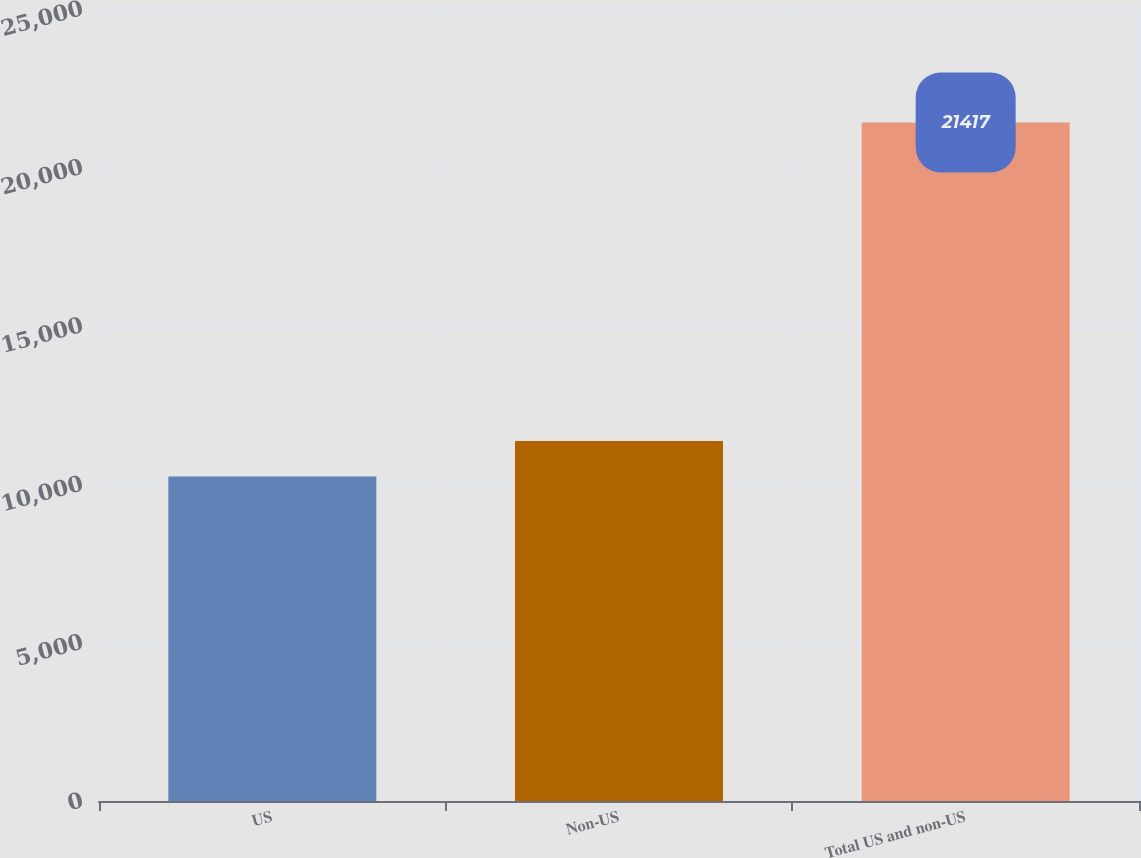Convert chart. <chart><loc_0><loc_0><loc_500><loc_500><bar_chart><fcel>US<fcel>Non-US<fcel>Total US and non-US<nl><fcel>10245<fcel>11362.2<fcel>21417<nl></chart> 